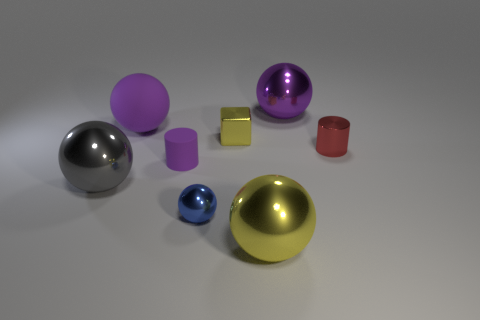Does the shiny cylinder have the same color as the tiny metal ball?
Offer a very short reply. No. There is a purple object that is on the left side of the tiny purple matte thing; is it the same size as the rubber thing in front of the yellow shiny block?
Offer a terse response. No. What is the color of the small thing on the right side of the yellow shiny block?
Your response must be concise. Red. What is the tiny object that is in front of the large gray ball that is left of the big yellow object made of?
Keep it short and to the point. Metal. There is a tiny yellow object; what shape is it?
Keep it short and to the point. Cube. What is the material of the other purple thing that is the same shape as the large rubber object?
Your answer should be compact. Metal. What number of gray spheres have the same size as the purple cylinder?
Provide a short and direct response. 0. There is a cylinder that is to the left of the tiny blue metallic sphere; is there a object that is to the left of it?
Make the answer very short. Yes. What number of purple objects are spheres or cylinders?
Offer a terse response. 3. What color is the rubber sphere?
Your answer should be very brief. Purple. 